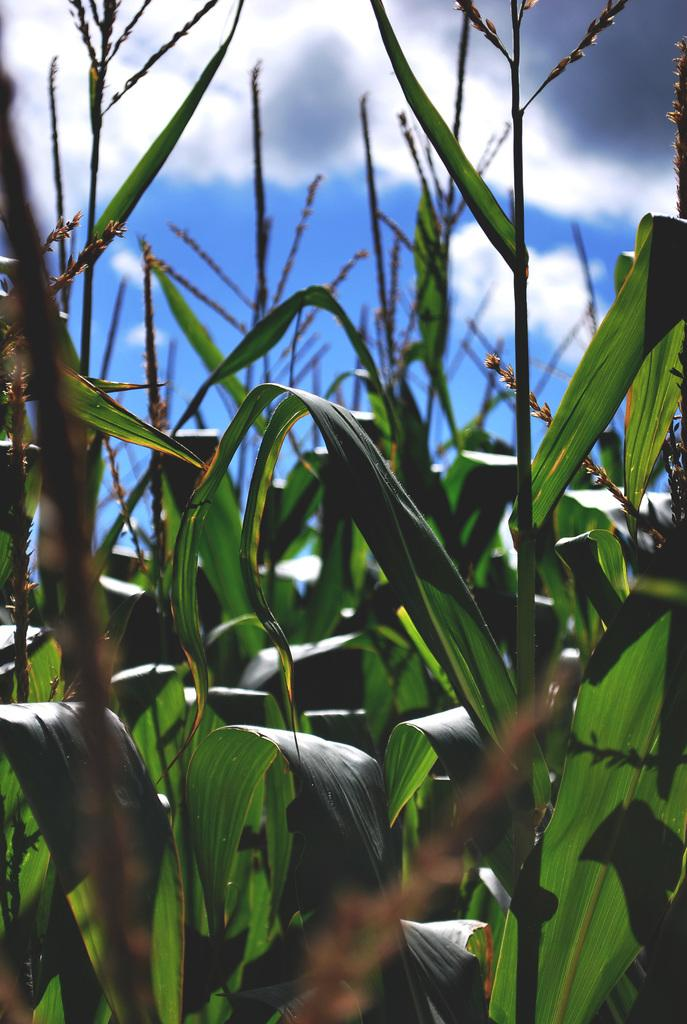What type of living organisms can be seen in the image? Plants can be seen in the image. What can be seen in the background of the image? There are clouds in the background of the image. What type of bone can be seen in the image? There is no bone present in the image; it features plants and clouds. What is the bucket used for in the image? There is no bucket present in the image. 